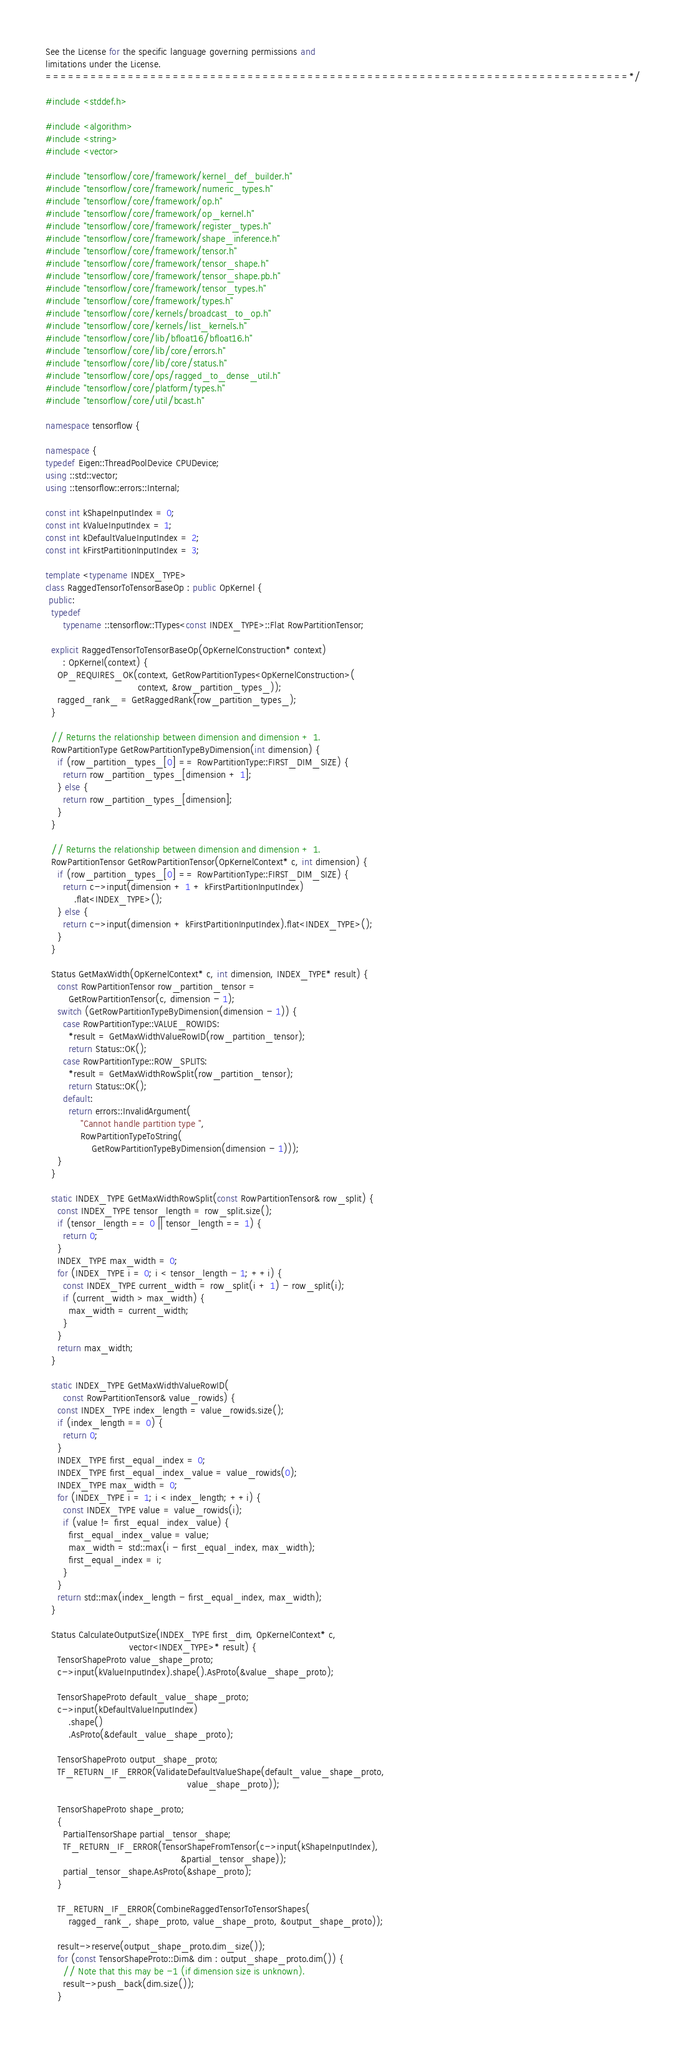<code> <loc_0><loc_0><loc_500><loc_500><_C++_>See the License for the specific language governing permissions and
limitations under the License.
==============================================================================*/

#include <stddef.h>

#include <algorithm>
#include <string>
#include <vector>

#include "tensorflow/core/framework/kernel_def_builder.h"
#include "tensorflow/core/framework/numeric_types.h"
#include "tensorflow/core/framework/op.h"
#include "tensorflow/core/framework/op_kernel.h"
#include "tensorflow/core/framework/register_types.h"
#include "tensorflow/core/framework/shape_inference.h"
#include "tensorflow/core/framework/tensor.h"
#include "tensorflow/core/framework/tensor_shape.h"
#include "tensorflow/core/framework/tensor_shape.pb.h"
#include "tensorflow/core/framework/tensor_types.h"
#include "tensorflow/core/framework/types.h"
#include "tensorflow/core/kernels/broadcast_to_op.h"
#include "tensorflow/core/kernels/list_kernels.h"
#include "tensorflow/core/lib/bfloat16/bfloat16.h"
#include "tensorflow/core/lib/core/errors.h"
#include "tensorflow/core/lib/core/status.h"
#include "tensorflow/core/ops/ragged_to_dense_util.h"
#include "tensorflow/core/platform/types.h"
#include "tensorflow/core/util/bcast.h"

namespace tensorflow {

namespace {
typedef Eigen::ThreadPoolDevice CPUDevice;
using ::std::vector;
using ::tensorflow::errors::Internal;

const int kShapeInputIndex = 0;
const int kValueInputIndex = 1;
const int kDefaultValueInputIndex = 2;
const int kFirstPartitionInputIndex = 3;

template <typename INDEX_TYPE>
class RaggedTensorToTensorBaseOp : public OpKernel {
 public:
  typedef
      typename ::tensorflow::TTypes<const INDEX_TYPE>::Flat RowPartitionTensor;

  explicit RaggedTensorToTensorBaseOp(OpKernelConstruction* context)
      : OpKernel(context) {
    OP_REQUIRES_OK(context, GetRowPartitionTypes<OpKernelConstruction>(
                                context, &row_partition_types_));
    ragged_rank_ = GetRaggedRank(row_partition_types_);
  }

  // Returns the relationship between dimension and dimension + 1.
  RowPartitionType GetRowPartitionTypeByDimension(int dimension) {
    if (row_partition_types_[0] == RowPartitionType::FIRST_DIM_SIZE) {
      return row_partition_types_[dimension + 1];
    } else {
      return row_partition_types_[dimension];
    }
  }

  // Returns the relationship between dimension and dimension + 1.
  RowPartitionTensor GetRowPartitionTensor(OpKernelContext* c, int dimension) {
    if (row_partition_types_[0] == RowPartitionType::FIRST_DIM_SIZE) {
      return c->input(dimension + 1 + kFirstPartitionInputIndex)
          .flat<INDEX_TYPE>();
    } else {
      return c->input(dimension + kFirstPartitionInputIndex).flat<INDEX_TYPE>();
    }
  }

  Status GetMaxWidth(OpKernelContext* c, int dimension, INDEX_TYPE* result) {
    const RowPartitionTensor row_partition_tensor =
        GetRowPartitionTensor(c, dimension - 1);
    switch (GetRowPartitionTypeByDimension(dimension - 1)) {
      case RowPartitionType::VALUE_ROWIDS:
        *result = GetMaxWidthValueRowID(row_partition_tensor);
        return Status::OK();
      case RowPartitionType::ROW_SPLITS:
        *result = GetMaxWidthRowSplit(row_partition_tensor);
        return Status::OK();
      default:
        return errors::InvalidArgument(
            "Cannot handle partition type ",
            RowPartitionTypeToString(
                GetRowPartitionTypeByDimension(dimension - 1)));
    }
  }

  static INDEX_TYPE GetMaxWidthRowSplit(const RowPartitionTensor& row_split) {
    const INDEX_TYPE tensor_length = row_split.size();
    if (tensor_length == 0 || tensor_length == 1) {
      return 0;
    }
    INDEX_TYPE max_width = 0;
    for (INDEX_TYPE i = 0; i < tensor_length - 1; ++i) {
      const INDEX_TYPE current_width = row_split(i + 1) - row_split(i);
      if (current_width > max_width) {
        max_width = current_width;
      }
    }
    return max_width;
  }

  static INDEX_TYPE GetMaxWidthValueRowID(
      const RowPartitionTensor& value_rowids) {
    const INDEX_TYPE index_length = value_rowids.size();
    if (index_length == 0) {
      return 0;
    }
    INDEX_TYPE first_equal_index = 0;
    INDEX_TYPE first_equal_index_value = value_rowids(0);
    INDEX_TYPE max_width = 0;
    for (INDEX_TYPE i = 1; i < index_length; ++i) {
      const INDEX_TYPE value = value_rowids(i);
      if (value != first_equal_index_value) {
        first_equal_index_value = value;
        max_width = std::max(i - first_equal_index, max_width);
        first_equal_index = i;
      }
    }
    return std::max(index_length - first_equal_index, max_width);
  }

  Status CalculateOutputSize(INDEX_TYPE first_dim, OpKernelContext* c,
                             vector<INDEX_TYPE>* result) {
    TensorShapeProto value_shape_proto;
    c->input(kValueInputIndex).shape().AsProto(&value_shape_proto);

    TensorShapeProto default_value_shape_proto;
    c->input(kDefaultValueInputIndex)
        .shape()
        .AsProto(&default_value_shape_proto);

    TensorShapeProto output_shape_proto;
    TF_RETURN_IF_ERROR(ValidateDefaultValueShape(default_value_shape_proto,
                                                 value_shape_proto));

    TensorShapeProto shape_proto;
    {
      PartialTensorShape partial_tensor_shape;
      TF_RETURN_IF_ERROR(TensorShapeFromTensor(c->input(kShapeInputIndex),
                                               &partial_tensor_shape));
      partial_tensor_shape.AsProto(&shape_proto);
    }

    TF_RETURN_IF_ERROR(CombineRaggedTensorToTensorShapes(
        ragged_rank_, shape_proto, value_shape_proto, &output_shape_proto));

    result->reserve(output_shape_proto.dim_size());
    for (const TensorShapeProto::Dim& dim : output_shape_proto.dim()) {
      // Note that this may be -1 (if dimension size is unknown).
      result->push_back(dim.size());
    }
</code> 